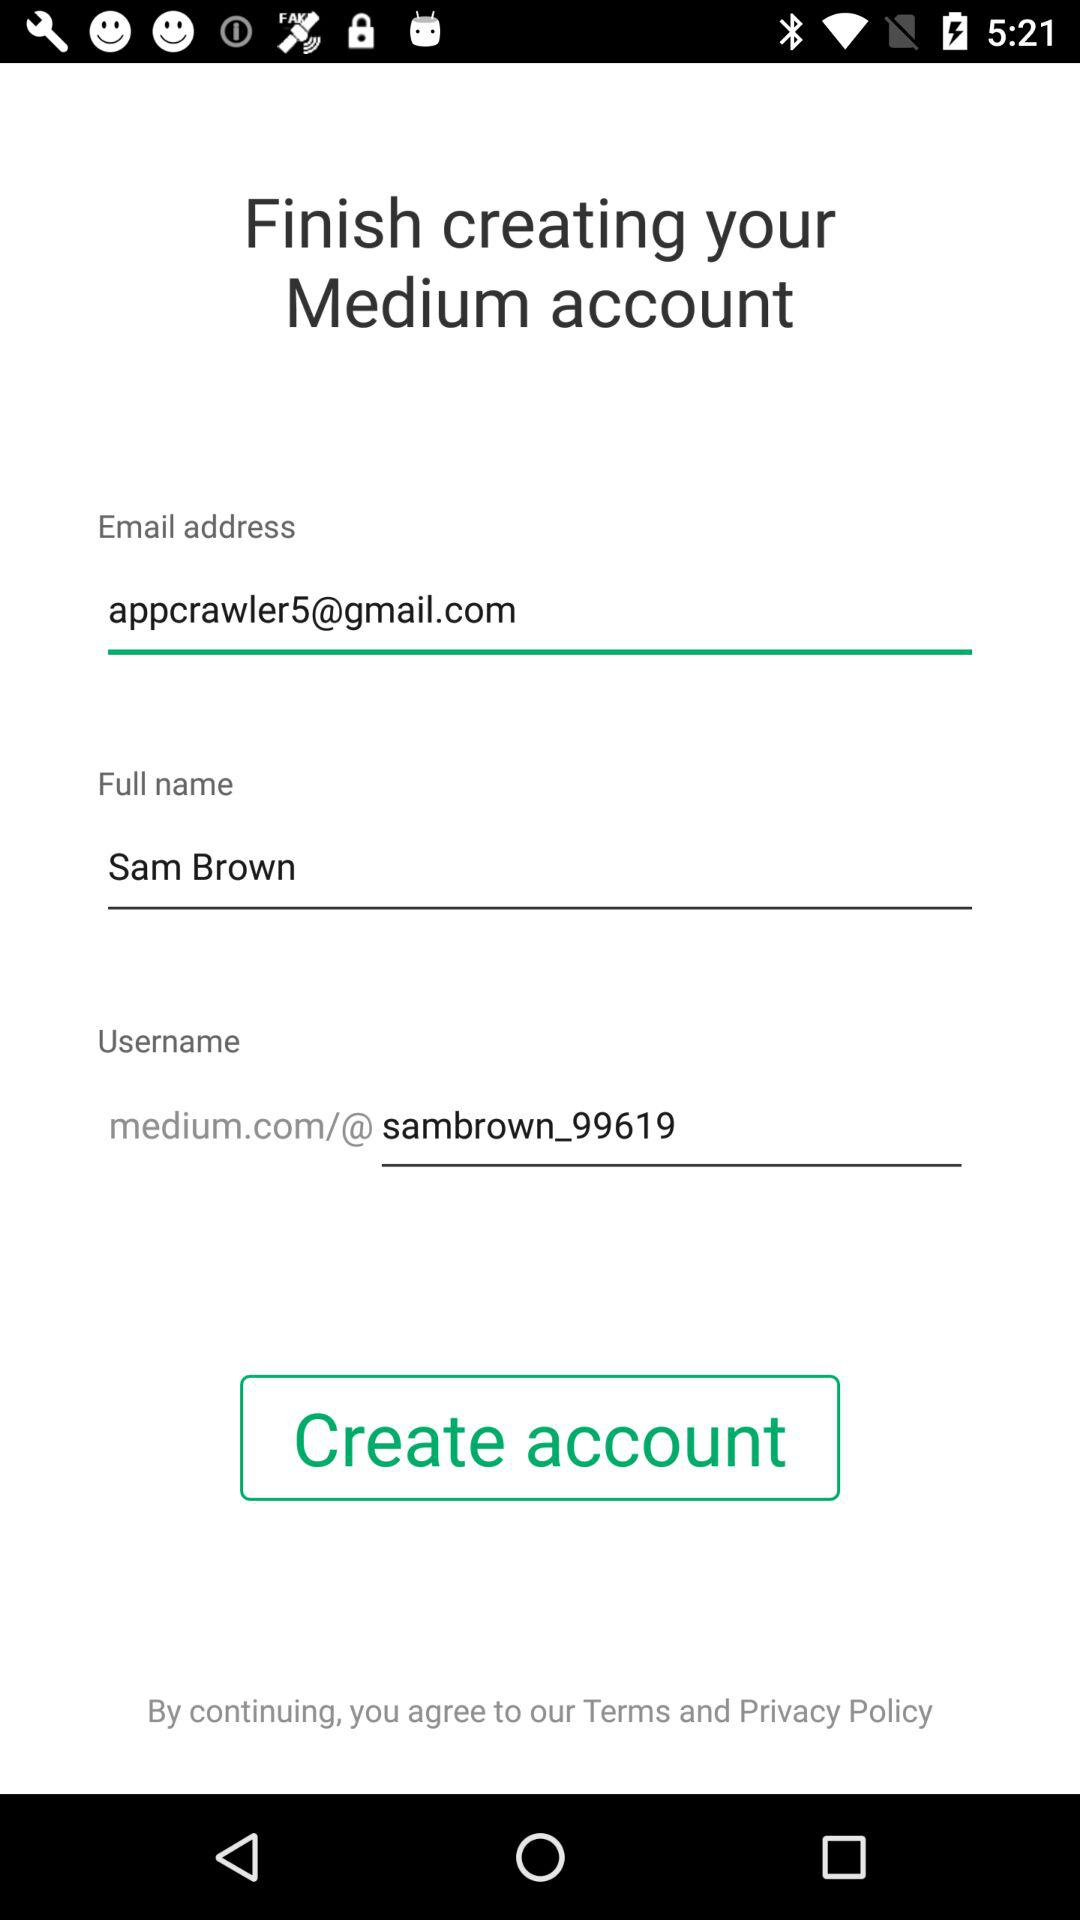What is the email address? The email address is appcrawler5@gmail.com. 